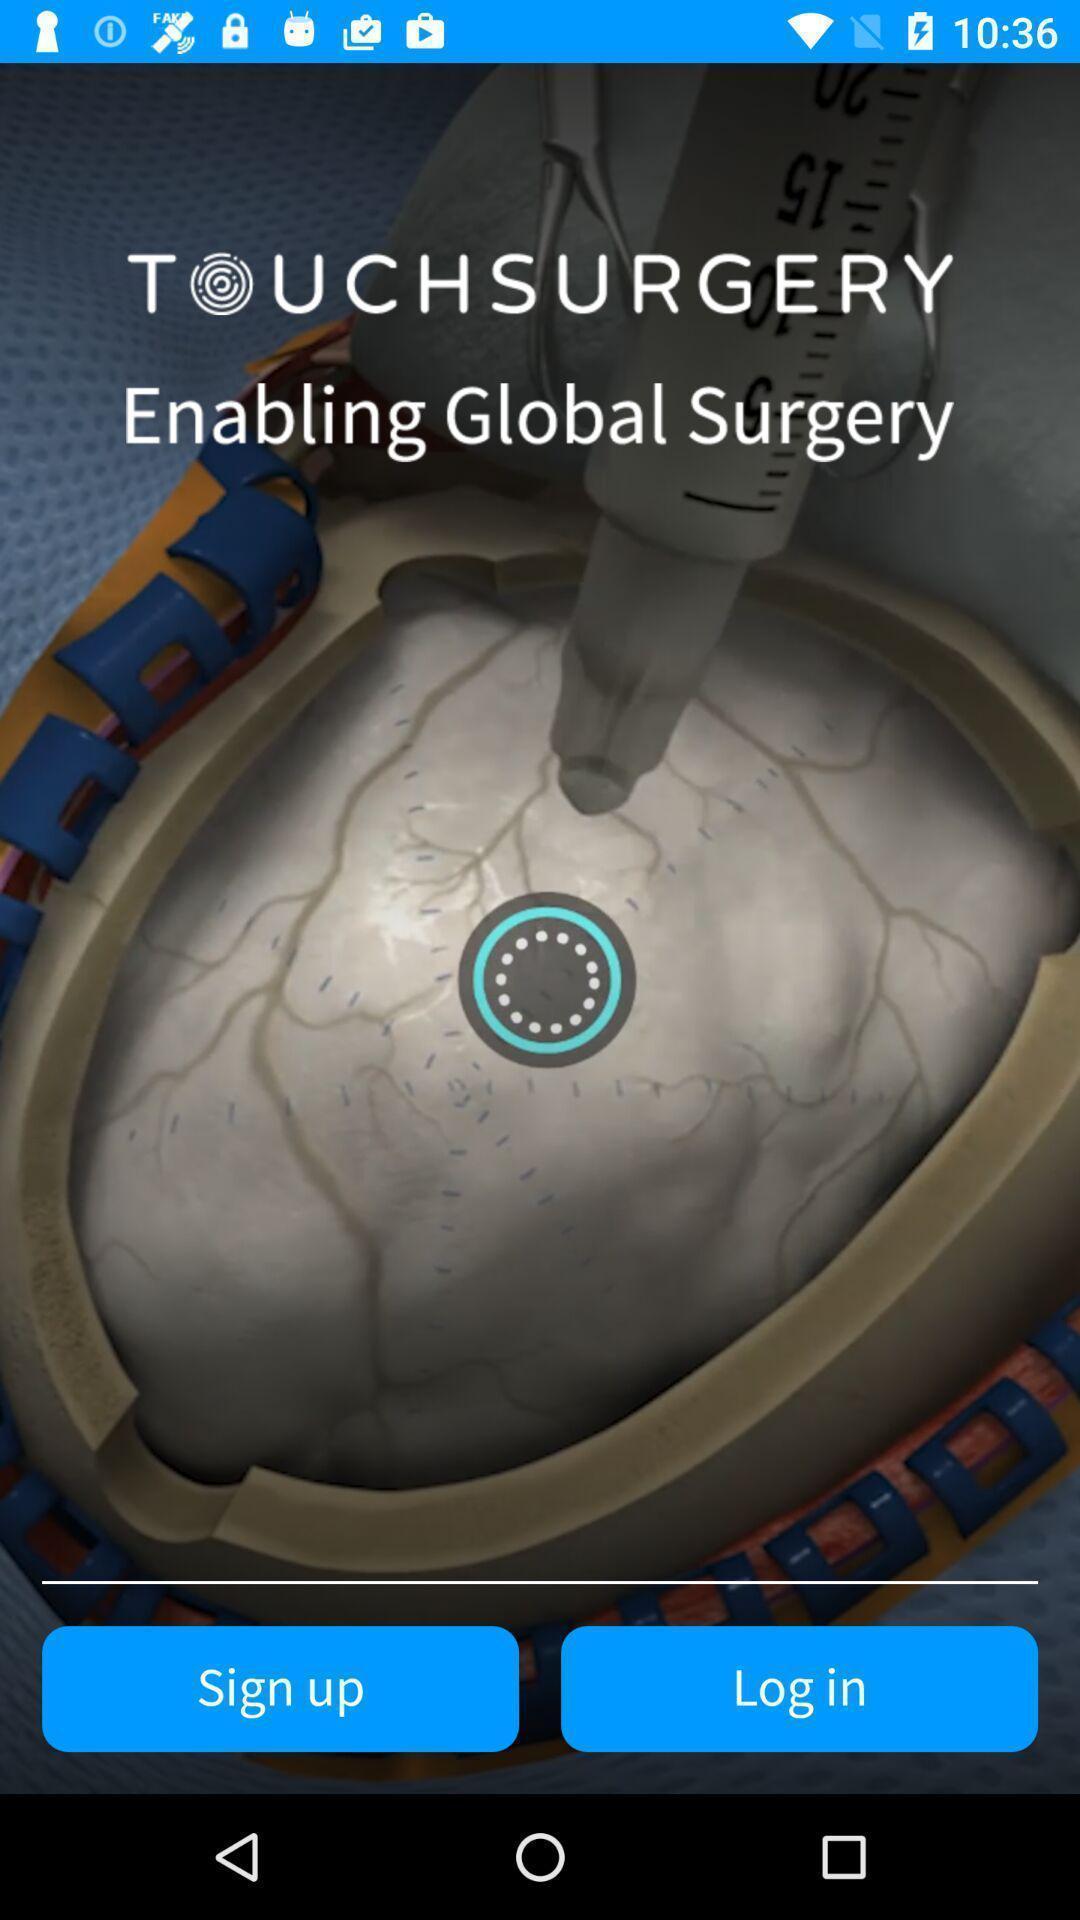Give me a summary of this screen capture. Welcome page for a surgery simulation based app. 